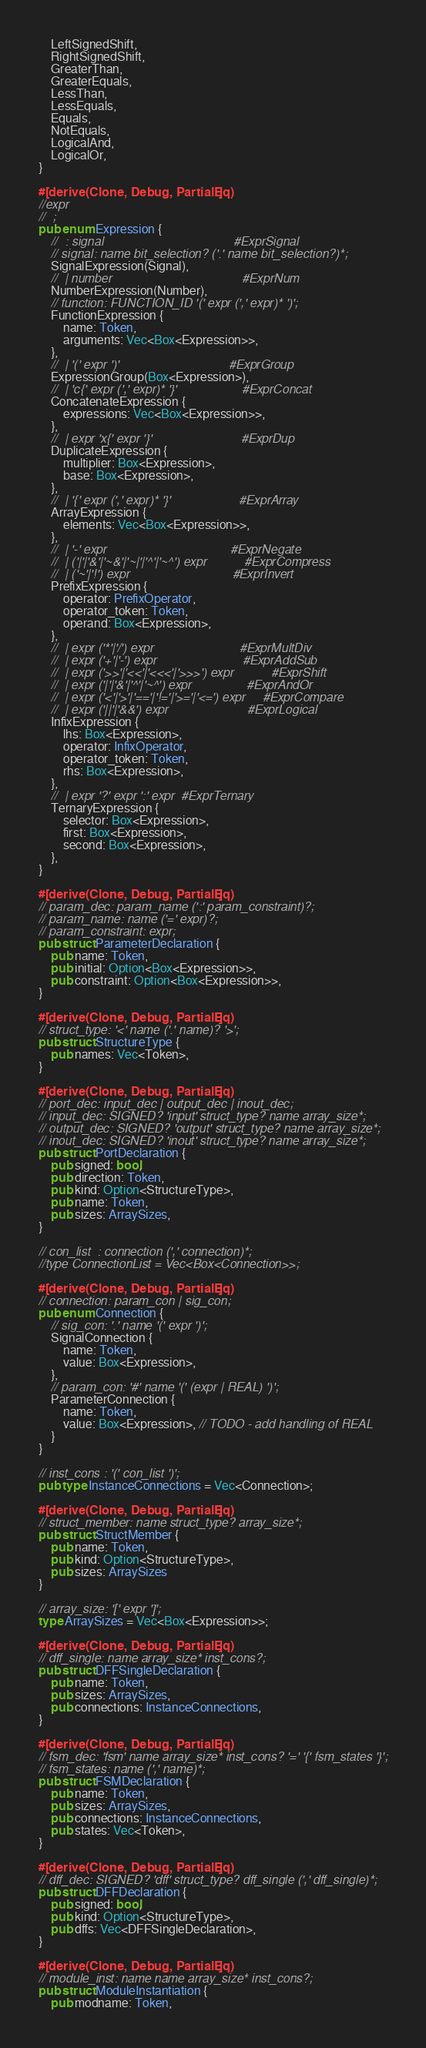<code> <loc_0><loc_0><loc_500><loc_500><_Rust_>    LeftSignedShift,
    RightSignedShift,
    GreaterThan,
    GreaterEquals,
    LessThan,
    LessEquals,
    Equals,
    NotEquals,
    LogicalAnd,
    LogicalOr,
}

#[derive(Clone, Debug, PartialEq)]
//expr
//  ;
pub enum Expression {
    //  : signal                                      #ExprSignal
    // signal: name bit_selection? ('.' name bit_selection?)*;
    SignalExpression(Signal),
    //  | number                                      #ExprNum
    NumberExpression(Number),
    // function: FUNCTION_ID '(' expr (',' expr)* ')';
    FunctionExpression {
        name: Token,
        arguments: Vec<Box<Expression>>,
    },
    //  | '(' expr ')'                                #ExprGroup
    ExpressionGroup(Box<Expression>),
    //  | 'c{' expr (',' expr)* '}'                   #ExprConcat
    ConcatenateExpression {
        expressions: Vec<Box<Expression>>,
    },
    //  | expr 'x{' expr '}'                          #ExprDup
    DuplicateExpression {
        multiplier: Box<Expression>,
        base: Box<Expression>,
    },
    //  | '{' expr (',' expr)* '}'                    #ExprArray
    ArrayExpression {
        elements: Vec<Box<Expression>>,
    },
    //  | '-' expr                                    #ExprNegate
    //  | ('|'|'&'|'~&'|'~|'|'^'|'~^') expr           #ExprCompress
    //  | ('~'|'!') expr                              #ExprInvert
    PrefixExpression {
        operator: PrefixOperator,
        operator_token: Token,
        operand: Box<Expression>,
    },
    //  | expr ('*'|'/') expr                         #ExprMultDiv
    //  | expr ('+'|'-') expr                         #ExprAddSub
    //  | expr ('>>'|'<<'|'<<<'|'>>>') expr           #ExprShift
    //  | expr ('|'|'&'|'^'|'~^') expr                #ExprAndOr
    //  | expr ('<'|'>'|'=='|'!='|'>='|'<=') expr     #ExprCompare
    //  | expr ('||'|'&&') expr                       #ExprLogical
    InfixExpression {
        lhs: Box<Expression>,
        operator: InfixOperator,
        operator_token: Token,
        rhs: Box<Expression>,
    },
    //  | expr '?' expr ':' expr  #ExprTernary
    TernaryExpression {
        selector: Box<Expression>,
        first: Box<Expression>,
        second: Box<Expression>,
    },
}

#[derive(Clone, Debug, PartialEq)]
// param_dec: param_name (':' param_constraint)?;
// param_name: name ('=' expr)?;
// param_constraint: expr;
pub struct ParameterDeclaration {
    pub name: Token,
    pub initial: Option<Box<Expression>>,
    pub constraint: Option<Box<Expression>>,
}

#[derive(Clone, Debug, PartialEq)]
// struct_type: '<' name ('.' name)? '>';
pub struct StructureType {
    pub names: Vec<Token>,
}

#[derive(Clone, Debug, PartialEq)]
// port_dec: input_dec | output_dec | inout_dec;
// input_dec: SIGNED? 'input' struct_type? name array_size*;
// output_dec: SIGNED? 'output' struct_type? name array_size*;
// inout_dec: SIGNED? 'inout' struct_type? name array_size*;
pub struct PortDeclaration {
    pub signed: bool,
    pub direction: Token,
    pub kind: Option<StructureType>,
    pub name: Token,
    pub sizes: ArraySizes,
}

// con_list  : connection (',' connection)*;
//type ConnectionList = Vec<Box<Connection>>;

#[derive(Clone, Debug, PartialEq)]
// connection: param_con | sig_con;
pub enum Connection {
    // sig_con: '.' name '(' expr ')';
    SignalConnection {
        name: Token,
        value: Box<Expression>,
    },
    // param_con: '#' name '(' (expr | REAL) ')';
    ParameterConnection {
        name: Token,
        value: Box<Expression>, // TODO - add handling of REAL
    }
}

// inst_cons : '(' con_list ')';
pub type InstanceConnections = Vec<Connection>;

#[derive(Clone, Debug, PartialEq)]
// struct_member: name struct_type? array_size*;
pub struct StructMember {
    pub name: Token,
    pub kind: Option<StructureType>,
    pub sizes: ArraySizes
}

// array_size: '[' expr ']';
type ArraySizes = Vec<Box<Expression>>;

#[derive(Clone, Debug, PartialEq)]
// dff_single: name array_size* inst_cons?;
pub struct DFFSingleDeclaration {
    pub name: Token,
    pub sizes: ArraySizes,
    pub connections: InstanceConnections,
}

#[derive(Clone, Debug, PartialEq)]
// fsm_dec: 'fsm' name array_size* inst_cons? '=' '{' fsm_states '}';
// fsm_states: name (',' name)*;
pub struct FSMDeclaration {
    pub name: Token,
    pub sizes: ArraySizes,
    pub connections: InstanceConnections,
    pub states: Vec<Token>,
}

#[derive(Clone, Debug, PartialEq)]
// dff_dec: SIGNED? 'dff' struct_type? dff_single (',' dff_single)*;
pub struct DFFDeclaration {
    pub signed: bool,
    pub kind: Option<StructureType>,
    pub dffs: Vec<DFFSingleDeclaration>,
}

#[derive(Clone, Debug, PartialEq)]
// module_inst: name name array_size* inst_cons?;
pub struct ModuleInstantiation {
    pub modname: Token,</code> 